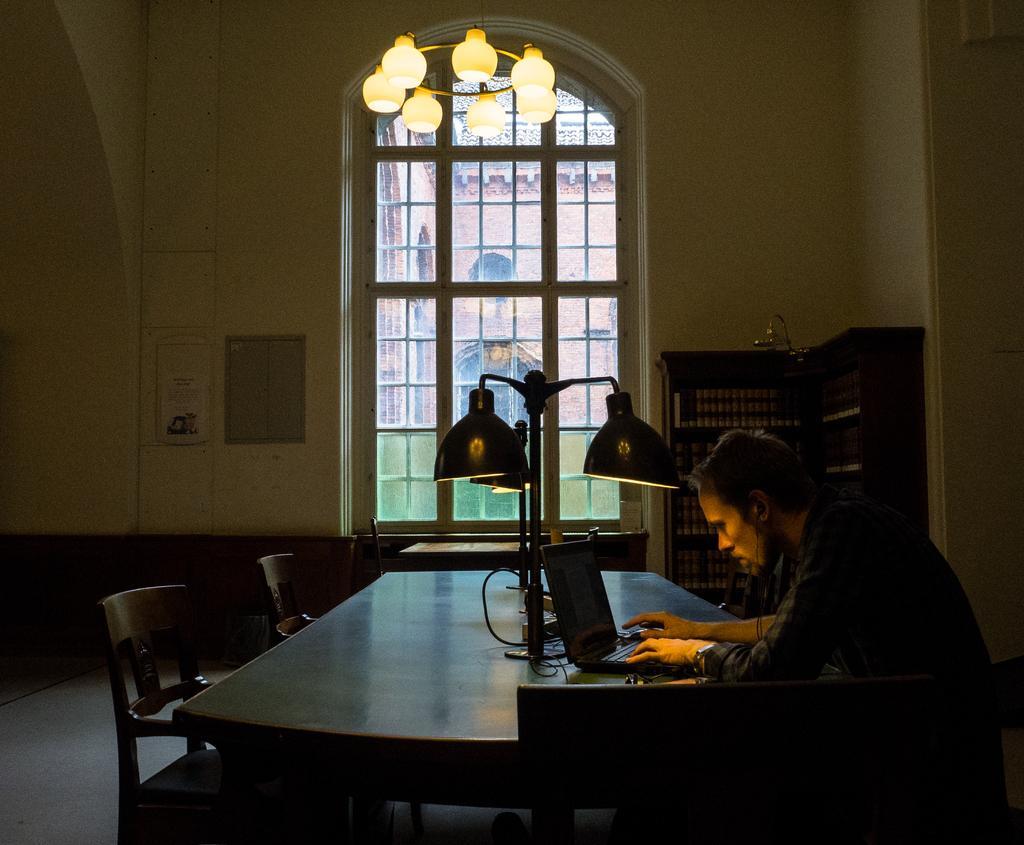Can you describe this image briefly? The person wearing a black shirt is sitting in a chair and operating laptop connected earphones to it. In background there is a window and a bookshelf. 